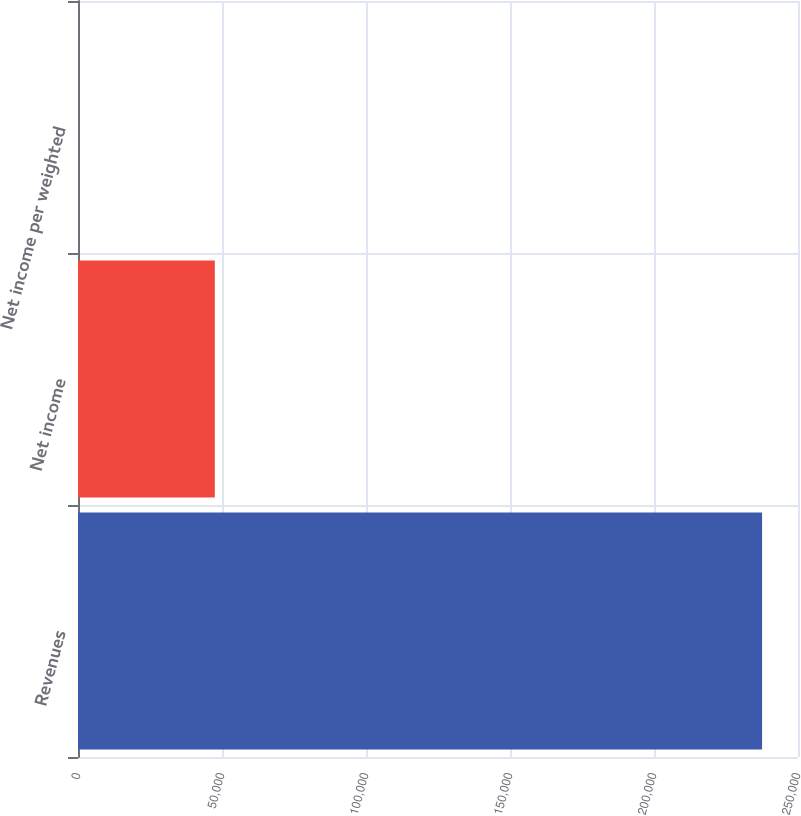<chart> <loc_0><loc_0><loc_500><loc_500><bar_chart><fcel>Revenues<fcel>Net income<fcel>Net income per weighted<nl><fcel>237523<fcel>47504.7<fcel>0.16<nl></chart> 